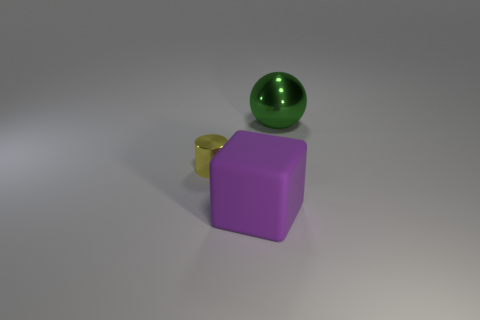What is the thing right of the big purple rubber cube made of?
Your answer should be compact. Metal. Is the shape of the purple thing the same as the metallic object left of the big rubber cube?
Provide a short and direct response. No. Is the number of tiny purple blocks greater than the number of shiny spheres?
Keep it short and to the point. No. Are there any other things of the same color as the small thing?
Your response must be concise. No. There is a large green object that is the same material as the small cylinder; what is its shape?
Your response must be concise. Sphere. There is a object that is right of the object in front of the small yellow metallic thing; what is its material?
Offer a very short reply. Metal. Are there more rubber objects left of the big shiny thing than large brown shiny cubes?
Offer a very short reply. Yes. Is there anything else that has the same material as the purple thing?
Keep it short and to the point. No. How many blocks are large matte objects or small objects?
Offer a terse response. 1. What color is the large thing behind the big thing left of the green ball?
Ensure brevity in your answer.  Green. 